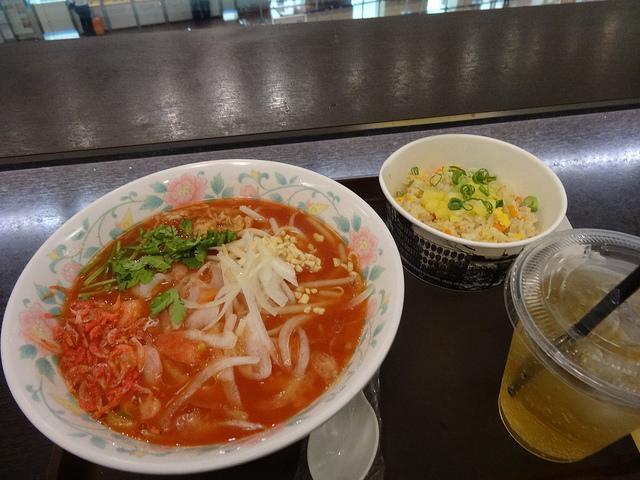How many bowls are there?
Give a very brief answer. 2. How many people are wearing glasses in this image?
Give a very brief answer. 0. 